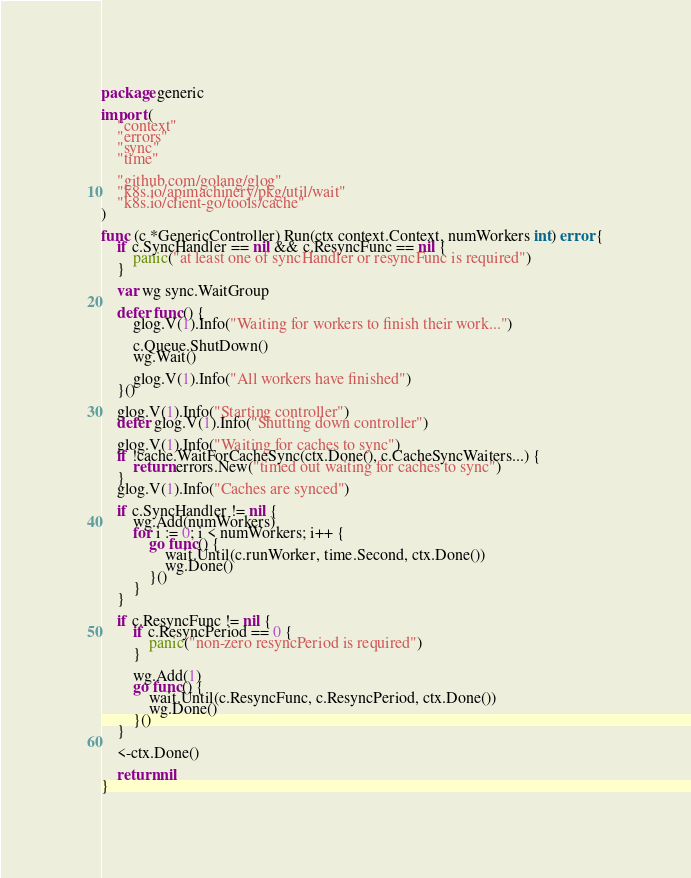<code> <loc_0><loc_0><loc_500><loc_500><_Go_>package generic

import (
	"context"
	"errors"
	"sync"
	"time"

	"github.com/golang/glog"
	"k8s.io/apimachinery/pkg/util/wait"
	"k8s.io/client-go/tools/cache"
)

func (c *GenericController) Run(ctx context.Context, numWorkers int) error {
	if c.SyncHandler == nil && c.ResyncFunc == nil {
		panic("at least one of syncHandler or resyncFunc is required")
	}

	var wg sync.WaitGroup

	defer func() {
		glog.V(1).Info("Waiting for workers to finish their work...")

		c.Queue.ShutDown()
		wg.Wait()

		glog.V(1).Info("All workers have finished")
	}()

	glog.V(1).Info("Starting controller")
	defer glog.V(1).Info("Shutting down controller")

	glog.V(1).Info("Waiting for caches to sync")
	if !cache.WaitForCacheSync(ctx.Done(), c.CacheSyncWaiters...) {
		return errors.New("timed out waiting for caches to sync")
	}
	glog.V(1).Info("Caches are synced")

	if c.SyncHandler != nil {
		wg.Add(numWorkers)
		for i := 0; i < numWorkers; i++ {
			go func() {
				wait.Until(c.runWorker, time.Second, ctx.Done())
				wg.Done()
			}()
		}
	}

	if c.ResyncFunc != nil {
		if c.ResyncPeriod == 0 {
			panic("non-zero resyncPeriod is required")
		}

		wg.Add(1)
		go func() {
			wait.Until(c.ResyncFunc, c.ResyncPeriod, ctx.Done())
			wg.Done()
		}()
	}

	<-ctx.Done()

	return nil
}
</code> 